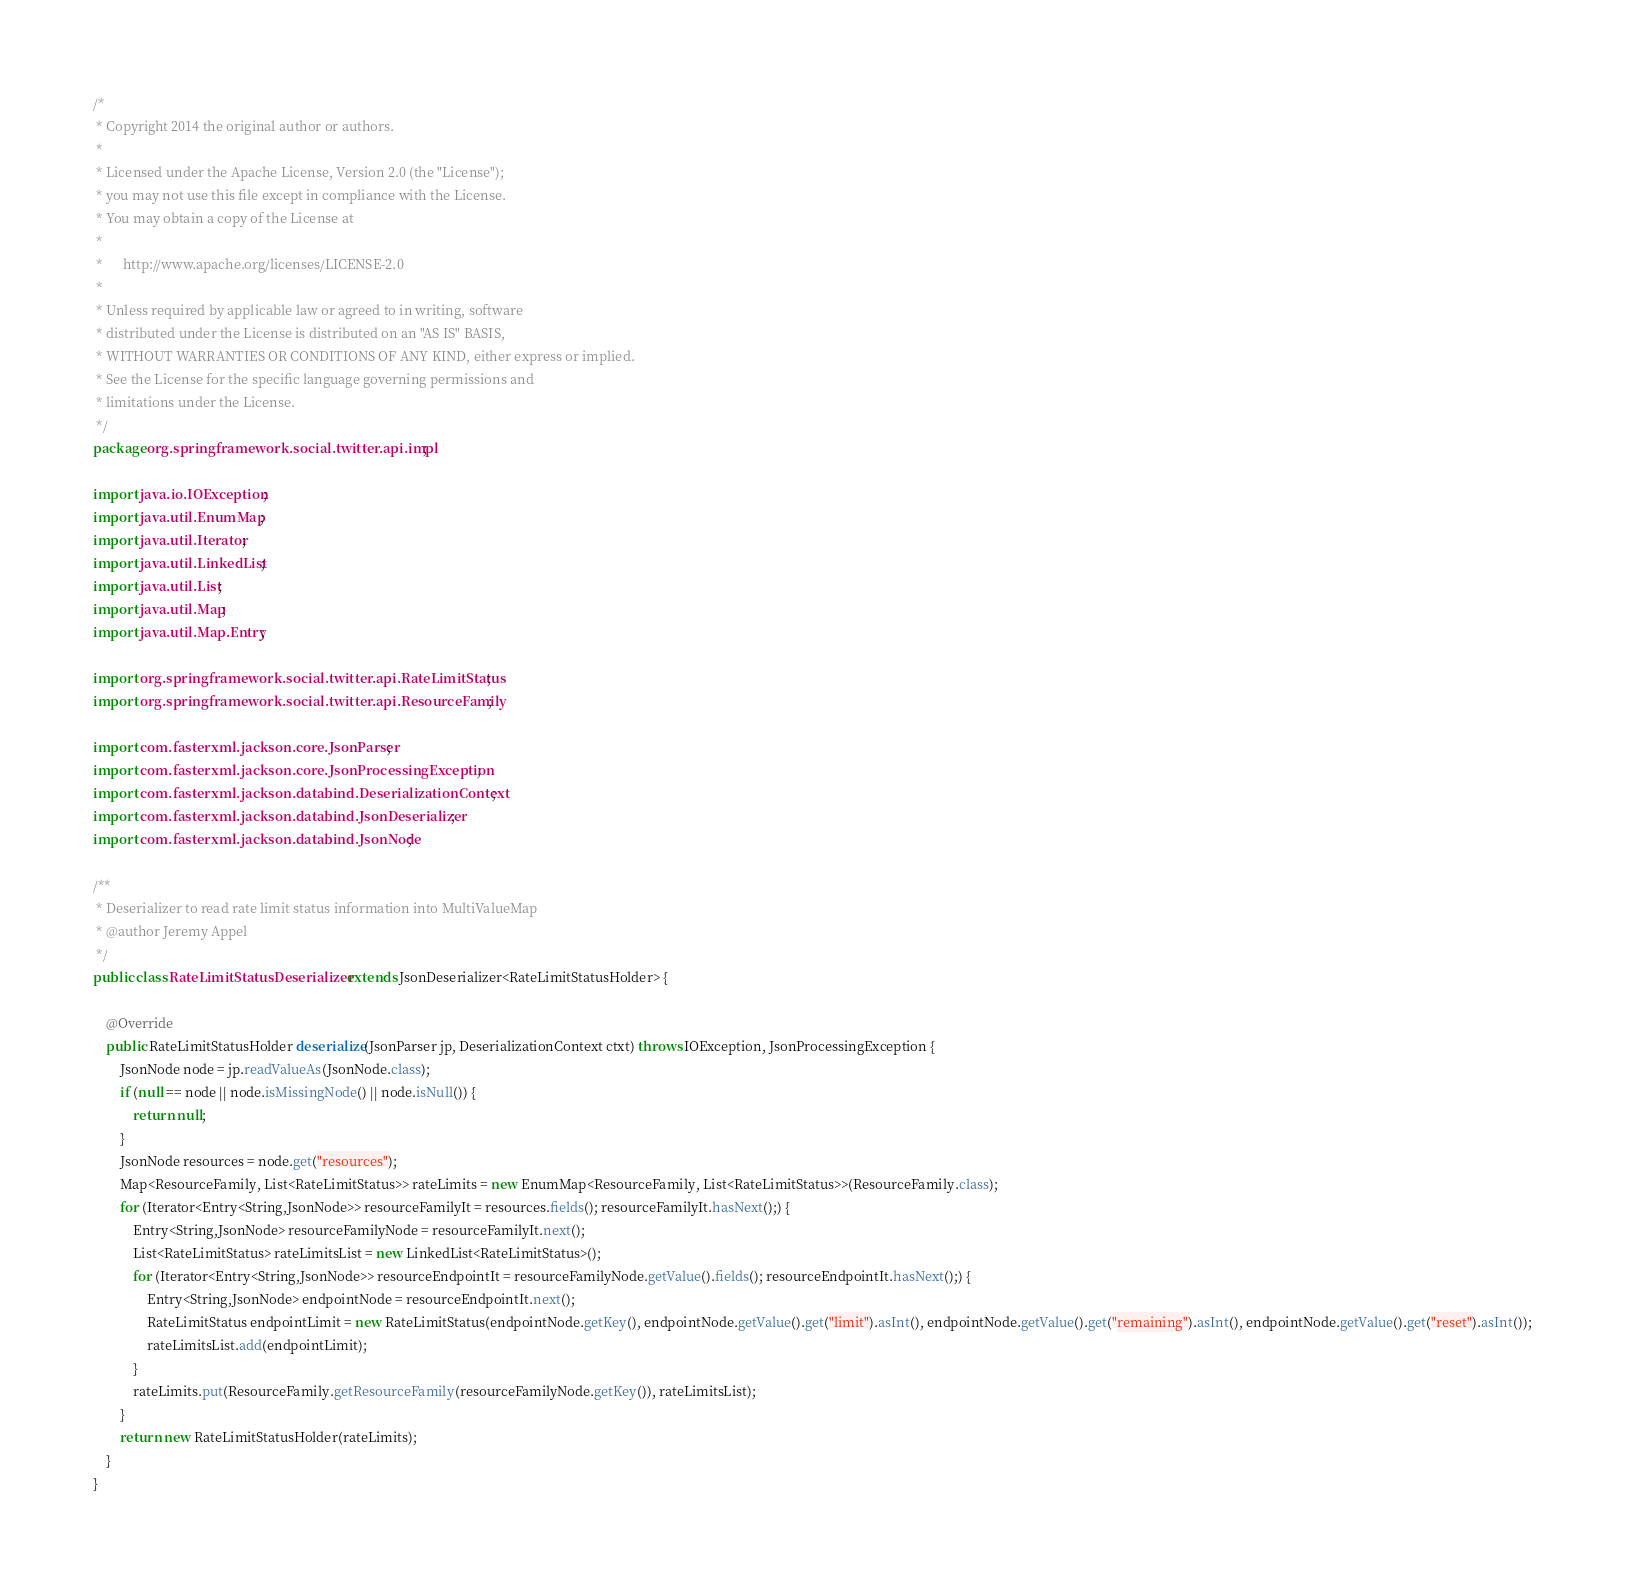Convert code to text. <code><loc_0><loc_0><loc_500><loc_500><_Java_>/*
 * Copyright 2014 the original author or authors.
 *
 * Licensed under the Apache License, Version 2.0 (the "License");
 * you may not use this file except in compliance with the License.
 * You may obtain a copy of the License at
 *
 *      http://www.apache.org/licenses/LICENSE-2.0
 *
 * Unless required by applicable law or agreed to in writing, software
 * distributed under the License is distributed on an "AS IS" BASIS,
 * WITHOUT WARRANTIES OR CONDITIONS OF ANY KIND, either express or implied.
 * See the License for the specific language governing permissions and
 * limitations under the License.
 */
package org.springframework.social.twitter.api.impl;

import java.io.IOException;
import java.util.EnumMap;
import java.util.Iterator;
import java.util.LinkedList;
import java.util.List;
import java.util.Map;
import java.util.Map.Entry;

import org.springframework.social.twitter.api.RateLimitStatus;
import org.springframework.social.twitter.api.ResourceFamily;

import com.fasterxml.jackson.core.JsonParser;
import com.fasterxml.jackson.core.JsonProcessingException;
import com.fasterxml.jackson.databind.DeserializationContext;
import com.fasterxml.jackson.databind.JsonDeserializer;
import com.fasterxml.jackson.databind.JsonNode;

/**
 * Deserializer to read rate limit status information into MultiValueMap
 * @author Jeremy Appel
 */
public class RateLimitStatusDeserializer extends JsonDeserializer<RateLimitStatusHolder> {

	@Override
	public RateLimitStatusHolder deserialize(JsonParser jp, DeserializationContext ctxt) throws IOException, JsonProcessingException {
		JsonNode node = jp.readValueAs(JsonNode.class);
		if (null == node || node.isMissingNode() || node.isNull()) {
			return null;
		}
		JsonNode resources = node.get("resources");
		Map<ResourceFamily, List<RateLimitStatus>> rateLimits = new EnumMap<ResourceFamily, List<RateLimitStatus>>(ResourceFamily.class);
		for (Iterator<Entry<String,JsonNode>> resourceFamilyIt = resources.fields(); resourceFamilyIt.hasNext();) {
			Entry<String,JsonNode> resourceFamilyNode = resourceFamilyIt.next();
			List<RateLimitStatus> rateLimitsList = new LinkedList<RateLimitStatus>();
			for (Iterator<Entry<String,JsonNode>> resourceEndpointIt = resourceFamilyNode.getValue().fields(); resourceEndpointIt.hasNext();) {
				Entry<String,JsonNode> endpointNode = resourceEndpointIt.next();
				RateLimitStatus endpointLimit = new RateLimitStatus(endpointNode.getKey(), endpointNode.getValue().get("limit").asInt(), endpointNode.getValue().get("remaining").asInt(), endpointNode.getValue().get("reset").asInt());
				rateLimitsList.add(endpointLimit);
			}
			rateLimits.put(ResourceFamily.getResourceFamily(resourceFamilyNode.getKey()), rateLimitsList);
		}
		return new RateLimitStatusHolder(rateLimits);
	}
}
</code> 